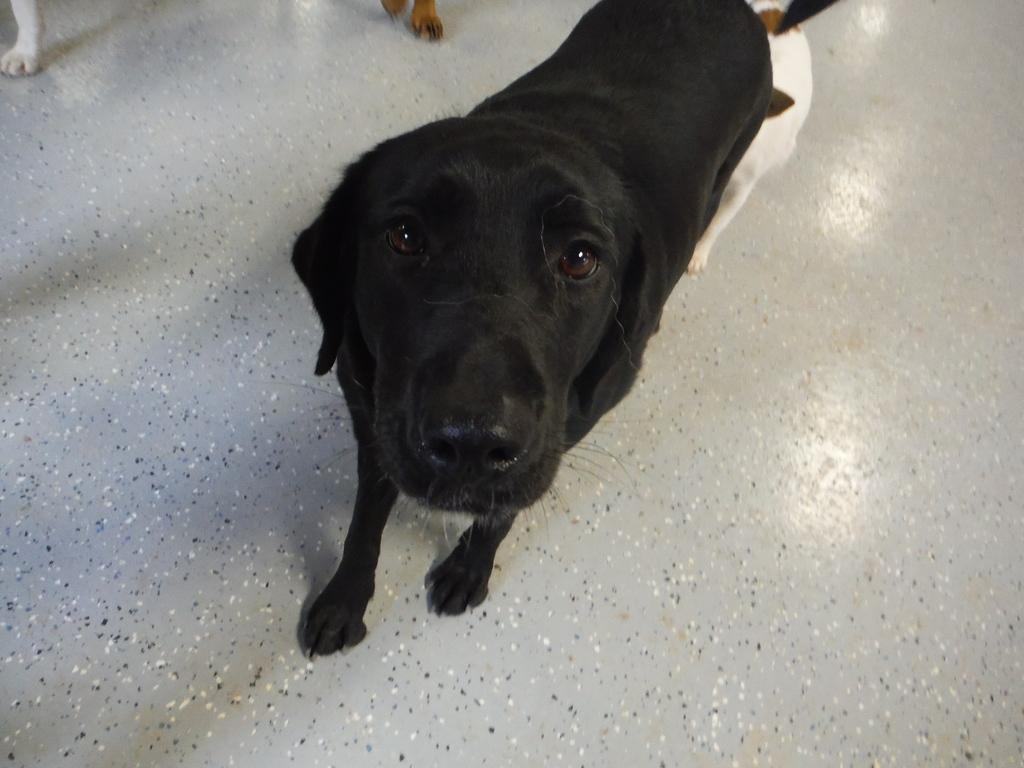What type of animals are in the image? There are dogs in the image. Where are the dogs located in the image? The dogs are standing on the floor. What colors can be seen on the dogs in the image? The dogs have black, white, and brown colors. What type of knot is the dog using to secure the yarn in the image? There is no knot or yarn present in the image; the dogs are simply standing on the floor with their respective colors. 